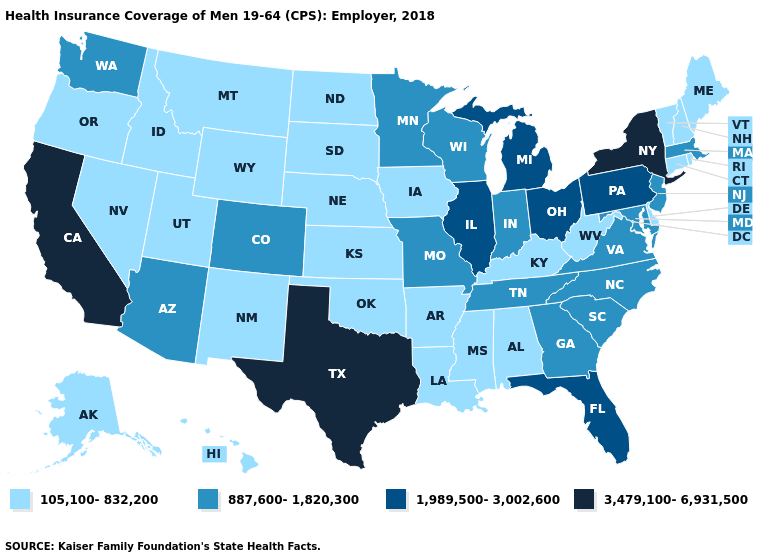Name the states that have a value in the range 3,479,100-6,931,500?
Write a very short answer. California, New York, Texas. Name the states that have a value in the range 1,989,500-3,002,600?
Be succinct. Florida, Illinois, Michigan, Ohio, Pennsylvania. Name the states that have a value in the range 3,479,100-6,931,500?
Write a very short answer. California, New York, Texas. Is the legend a continuous bar?
Give a very brief answer. No. How many symbols are there in the legend?
Short answer required. 4. What is the value of Florida?
Answer briefly. 1,989,500-3,002,600. What is the highest value in the USA?
Short answer required. 3,479,100-6,931,500. Among the states that border New Hampshire , does Massachusetts have the highest value?
Write a very short answer. Yes. What is the value of Texas?
Be succinct. 3,479,100-6,931,500. Which states hav the highest value in the South?
Give a very brief answer. Texas. Which states have the lowest value in the Northeast?
Quick response, please. Connecticut, Maine, New Hampshire, Rhode Island, Vermont. Does Washington have the highest value in the West?
Be succinct. No. Name the states that have a value in the range 105,100-832,200?
Concise answer only. Alabama, Alaska, Arkansas, Connecticut, Delaware, Hawaii, Idaho, Iowa, Kansas, Kentucky, Louisiana, Maine, Mississippi, Montana, Nebraska, Nevada, New Hampshire, New Mexico, North Dakota, Oklahoma, Oregon, Rhode Island, South Dakota, Utah, Vermont, West Virginia, Wyoming. Does West Virginia have the lowest value in the USA?
Keep it brief. Yes. Is the legend a continuous bar?
Concise answer only. No. 